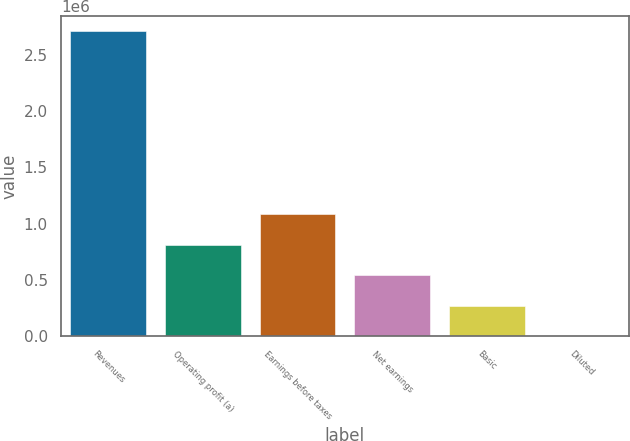<chart> <loc_0><loc_0><loc_500><loc_500><bar_chart><fcel>Revenues<fcel>Operating profit (a)<fcel>Earnings before taxes<fcel>Net earnings<fcel>Basic<fcel>Diluted<nl><fcel>2.70672e+06<fcel>812018<fcel>1.08269e+06<fcel>541345<fcel>270673<fcel>0.76<nl></chart> 